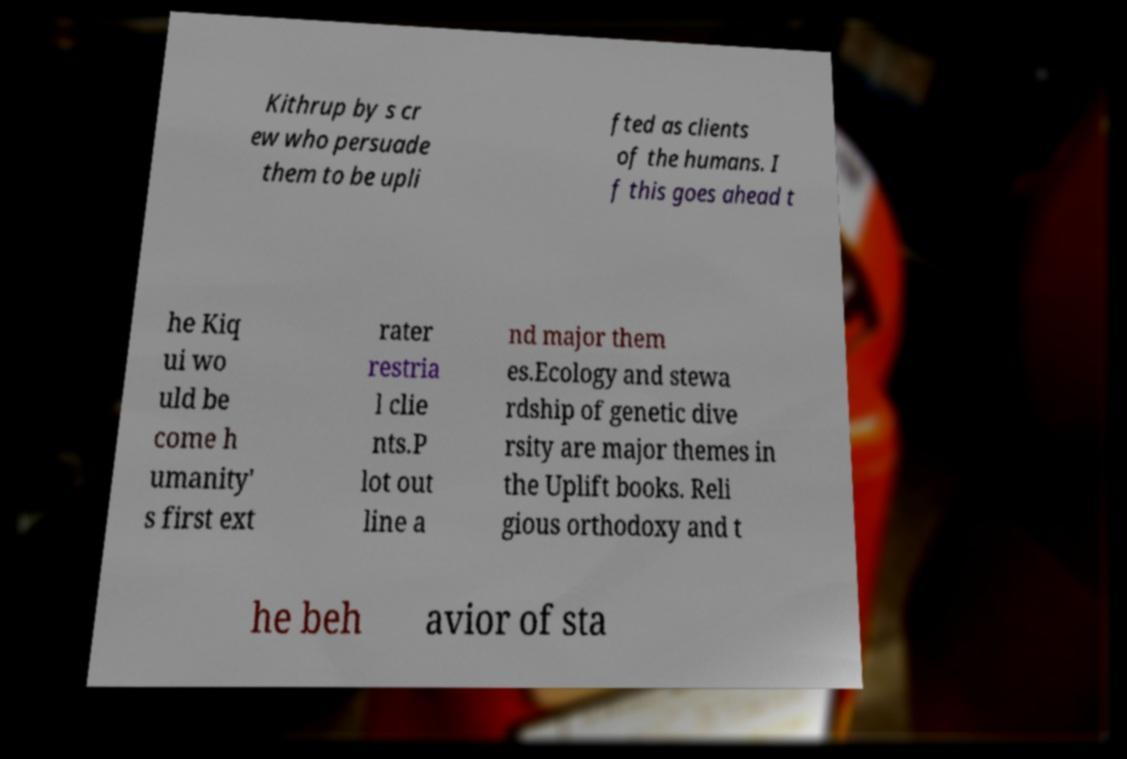Please identify and transcribe the text found in this image. Kithrup by s cr ew who persuade them to be upli fted as clients of the humans. I f this goes ahead t he Kiq ui wo uld be come h umanity' s first ext rater restria l clie nts.P lot out line a nd major them es.Ecology and stewa rdship of genetic dive rsity are major themes in the Uplift books. Reli gious orthodoxy and t he beh avior of sta 